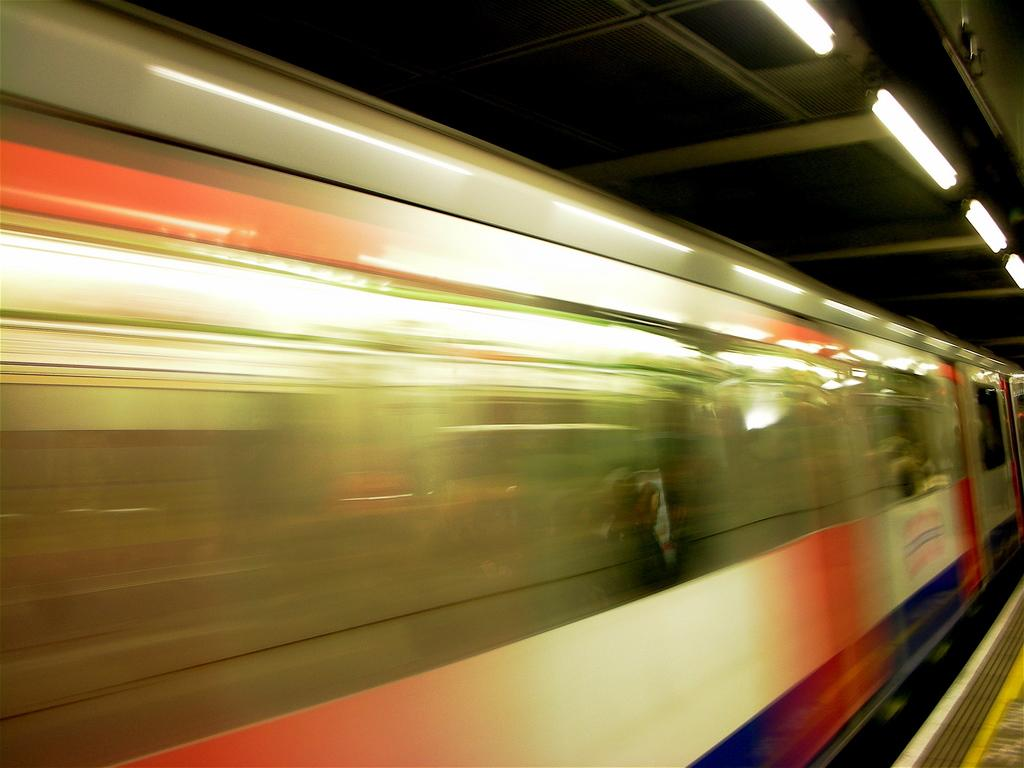What is the main subject of the image? There is a train in the image. What is the train doing in the image? The train is moving on a track. Where is the platform located in the image? There is a platform at the bottom right of the image. What is visible above the train in the image? There is a roof visible in the image. What can be seen providing illumination in the image? There are lights present in the image. What type of test is being conducted on the train in the image? There is no indication of a test being conducted on the train in the image. Can you tell me how many tubs are visible on the train in the image? There are no tubs visible on the train in the image. 